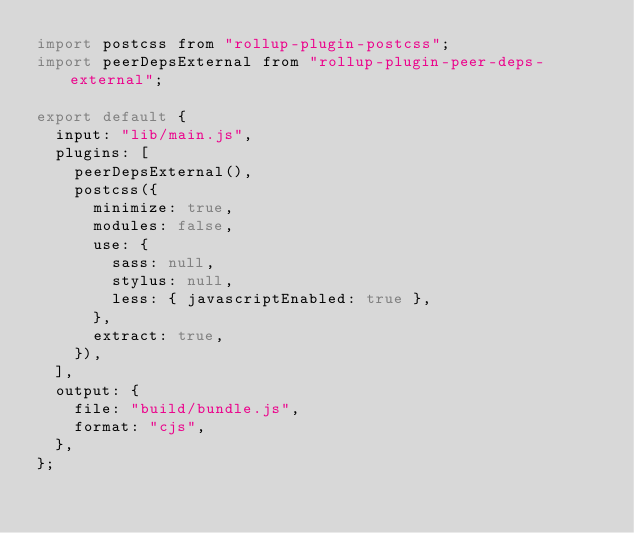Convert code to text. <code><loc_0><loc_0><loc_500><loc_500><_JavaScript_>import postcss from "rollup-plugin-postcss";
import peerDepsExternal from "rollup-plugin-peer-deps-external";

export default {
  input: "lib/main.js",
  plugins: [
    peerDepsExternal(),
    postcss({
      minimize: true,
      modules: false,
      use: {
        sass: null,
        stylus: null,
        less: { javascriptEnabled: true },
      },
      extract: true,
    }),
  ],
  output: {
    file: "build/bundle.js",
    format: "cjs",
  },
};
</code> 